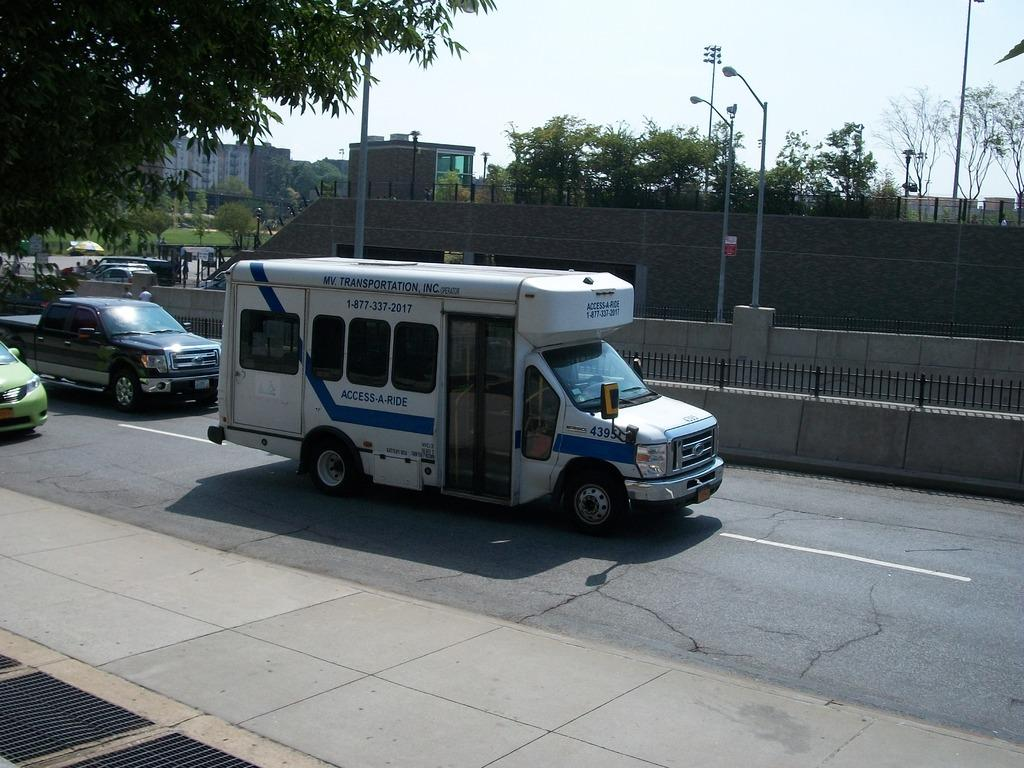What is happening on the road in the image? There are vehicles moving on the road in the image. What structures can be seen along the road? Street light poles are visible in the image. What type of vegetation is present in the image? Trees are visible in the image. What type of man-made structures are present in the image? Buildings are present in the image. What can be seen in the background of the image? The sky is visible in the background of the image. What type of mask is the tree wearing in the image? There are no masks present in the image, and trees do not wear masks. 